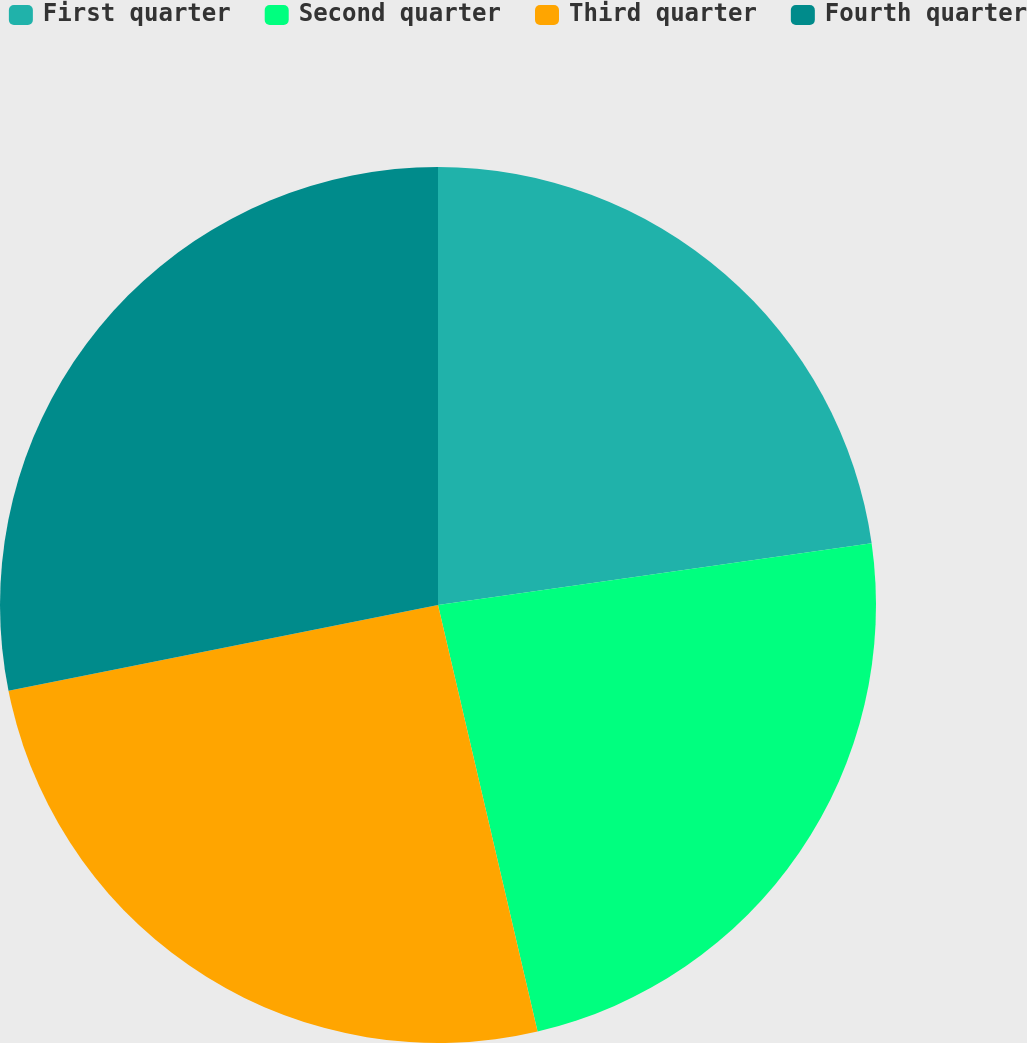Convert chart. <chart><loc_0><loc_0><loc_500><loc_500><pie_chart><fcel>First quarter<fcel>Second quarter<fcel>Third quarter<fcel>Fourth quarter<nl><fcel>22.75%<fcel>23.6%<fcel>25.51%<fcel>28.14%<nl></chart> 